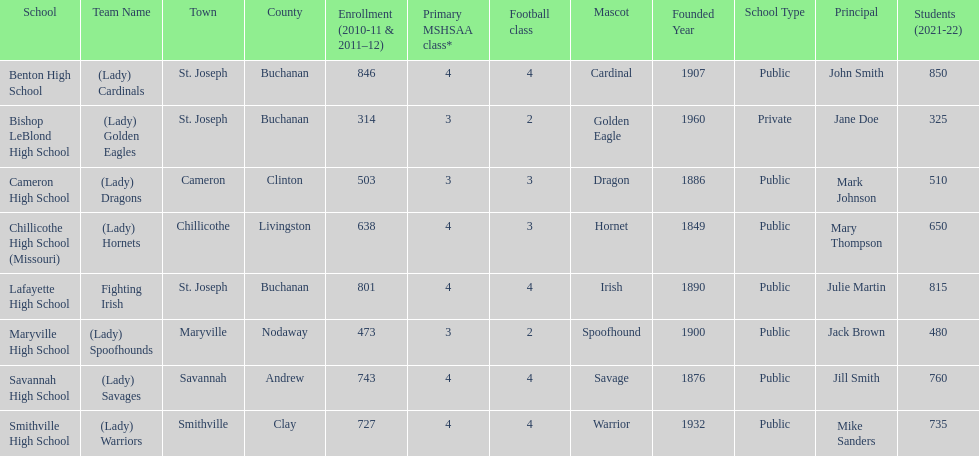What is the lowest number of students enrolled at a school as listed here? 314. What school has 314 students enrolled? Bishop LeBlond High School. 